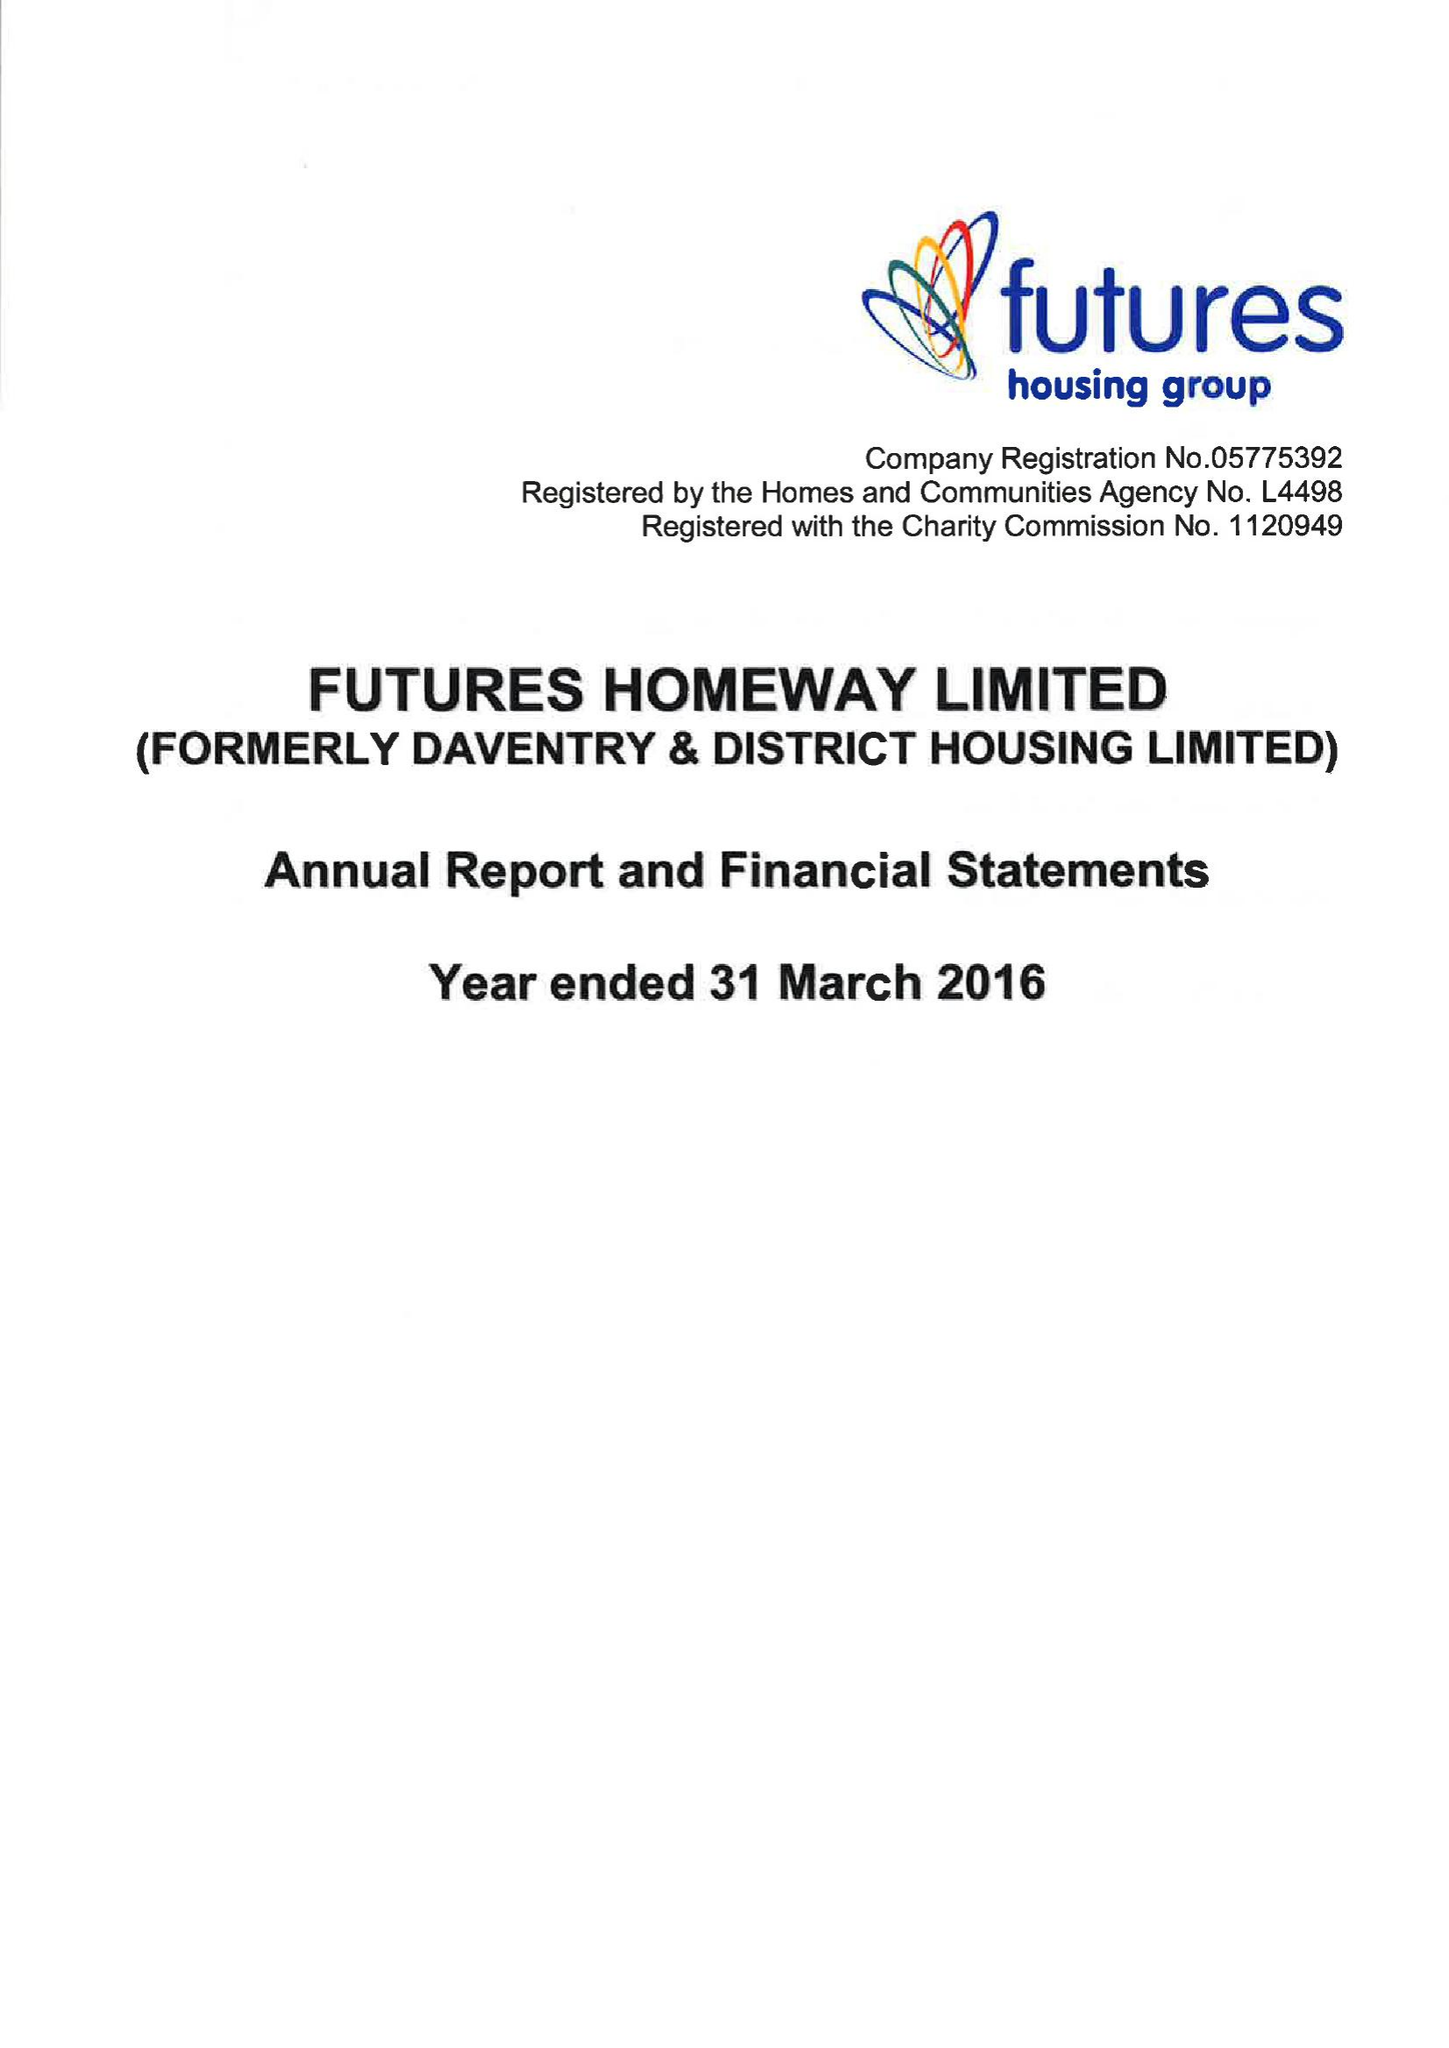What is the value for the income_annually_in_british_pounds?
Answer the question using a single word or phrase. 16442000.00 